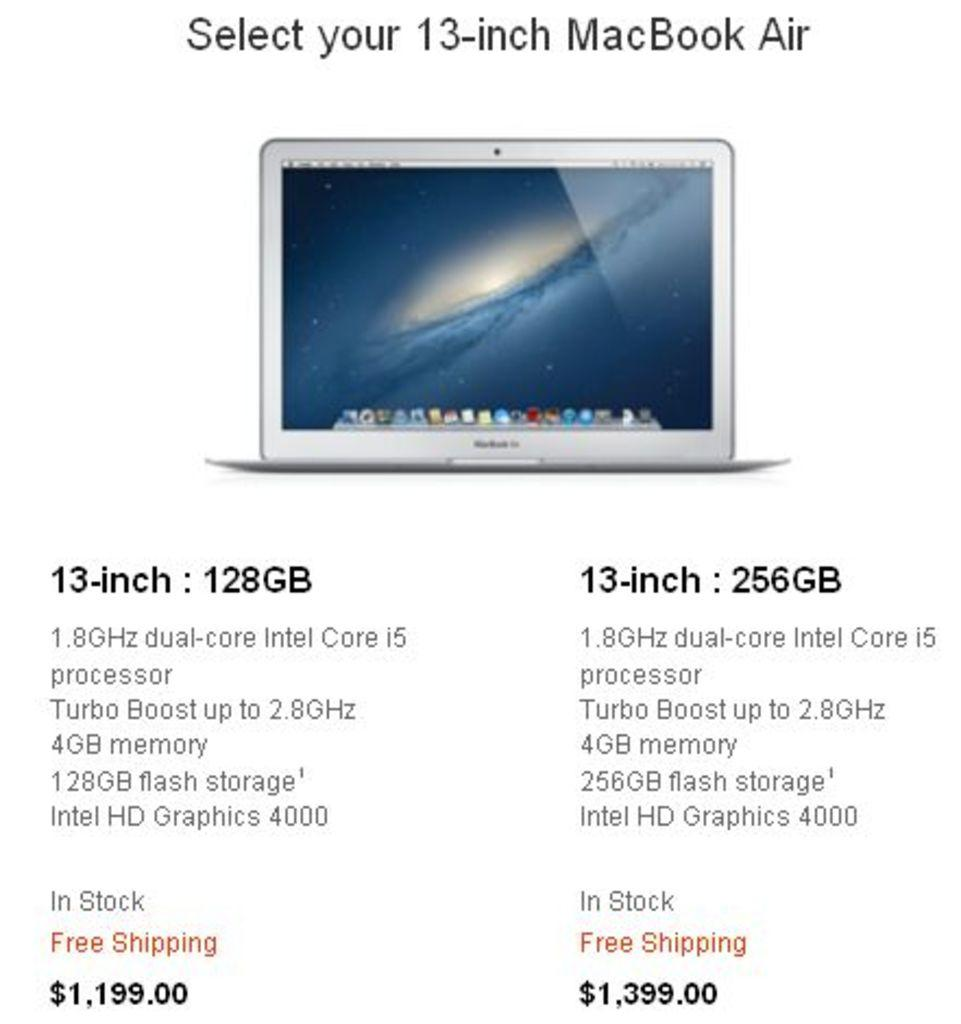<image>
Create a compact narrative representing the image presented. Memory options for a MacBook air include 128 gigabytes and 256 gigabytes. 